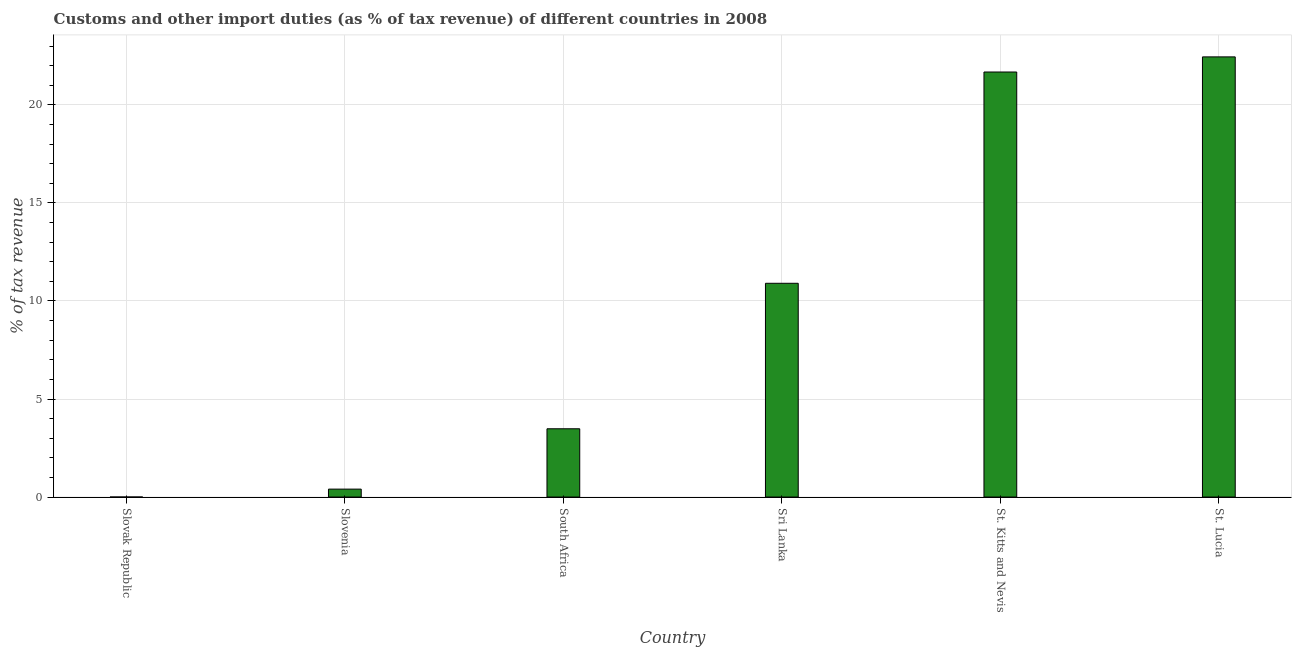Does the graph contain grids?
Offer a very short reply. Yes. What is the title of the graph?
Your answer should be compact. Customs and other import duties (as % of tax revenue) of different countries in 2008. What is the label or title of the X-axis?
Your answer should be very brief. Country. What is the label or title of the Y-axis?
Your answer should be very brief. % of tax revenue. What is the customs and other import duties in South Africa?
Your answer should be compact. 3.48. Across all countries, what is the maximum customs and other import duties?
Make the answer very short. 22.45. Across all countries, what is the minimum customs and other import duties?
Provide a short and direct response. 0. In which country was the customs and other import duties maximum?
Give a very brief answer. St. Lucia. In which country was the customs and other import duties minimum?
Your response must be concise. Slovak Republic. What is the sum of the customs and other import duties?
Ensure brevity in your answer.  58.92. What is the difference between the customs and other import duties in Slovenia and St. Lucia?
Provide a short and direct response. -22.05. What is the average customs and other import duties per country?
Offer a terse response. 9.82. What is the median customs and other import duties?
Your response must be concise. 7.19. In how many countries, is the customs and other import duties greater than 5 %?
Offer a terse response. 3. What is the ratio of the customs and other import duties in St. Kitts and Nevis to that in St. Lucia?
Offer a very short reply. 0.97. Is the customs and other import duties in Slovak Republic less than that in Sri Lanka?
Offer a very short reply. Yes. Is the difference between the customs and other import duties in South Africa and St. Lucia greater than the difference between any two countries?
Your answer should be very brief. No. What is the difference between the highest and the second highest customs and other import duties?
Give a very brief answer. 0.77. What is the difference between the highest and the lowest customs and other import duties?
Offer a very short reply. 22.45. How many bars are there?
Provide a succinct answer. 6. How many countries are there in the graph?
Keep it short and to the point. 6. What is the difference between two consecutive major ticks on the Y-axis?
Provide a succinct answer. 5. What is the % of tax revenue in Slovak Republic?
Your answer should be very brief. 0. What is the % of tax revenue in Slovenia?
Provide a succinct answer. 0.4. What is the % of tax revenue of South Africa?
Give a very brief answer. 3.48. What is the % of tax revenue in Sri Lanka?
Your answer should be very brief. 10.9. What is the % of tax revenue of St. Kitts and Nevis?
Keep it short and to the point. 21.68. What is the % of tax revenue of St. Lucia?
Provide a short and direct response. 22.45. What is the difference between the % of tax revenue in Slovak Republic and Slovenia?
Ensure brevity in your answer.  -0.4. What is the difference between the % of tax revenue in Slovak Republic and South Africa?
Provide a succinct answer. -3.48. What is the difference between the % of tax revenue in Slovak Republic and Sri Lanka?
Your response must be concise. -10.9. What is the difference between the % of tax revenue in Slovak Republic and St. Kitts and Nevis?
Keep it short and to the point. -21.68. What is the difference between the % of tax revenue in Slovak Republic and St. Lucia?
Your answer should be compact. -22.45. What is the difference between the % of tax revenue in Slovenia and South Africa?
Offer a very short reply. -3.08. What is the difference between the % of tax revenue in Slovenia and Sri Lanka?
Provide a succinct answer. -10.5. What is the difference between the % of tax revenue in Slovenia and St. Kitts and Nevis?
Provide a short and direct response. -21.27. What is the difference between the % of tax revenue in Slovenia and St. Lucia?
Offer a terse response. -22.05. What is the difference between the % of tax revenue in South Africa and Sri Lanka?
Ensure brevity in your answer.  -7.42. What is the difference between the % of tax revenue in South Africa and St. Kitts and Nevis?
Your response must be concise. -18.2. What is the difference between the % of tax revenue in South Africa and St. Lucia?
Offer a terse response. -18.97. What is the difference between the % of tax revenue in Sri Lanka and St. Kitts and Nevis?
Provide a succinct answer. -10.78. What is the difference between the % of tax revenue in Sri Lanka and St. Lucia?
Provide a short and direct response. -11.55. What is the difference between the % of tax revenue in St. Kitts and Nevis and St. Lucia?
Make the answer very short. -0.77. What is the ratio of the % of tax revenue in Slovak Republic to that in St. Lucia?
Your response must be concise. 0. What is the ratio of the % of tax revenue in Slovenia to that in South Africa?
Give a very brief answer. 0.12. What is the ratio of the % of tax revenue in Slovenia to that in Sri Lanka?
Offer a very short reply. 0.04. What is the ratio of the % of tax revenue in Slovenia to that in St. Kitts and Nevis?
Your answer should be very brief. 0.02. What is the ratio of the % of tax revenue in Slovenia to that in St. Lucia?
Your response must be concise. 0.02. What is the ratio of the % of tax revenue in South Africa to that in Sri Lanka?
Give a very brief answer. 0.32. What is the ratio of the % of tax revenue in South Africa to that in St. Kitts and Nevis?
Offer a very short reply. 0.16. What is the ratio of the % of tax revenue in South Africa to that in St. Lucia?
Ensure brevity in your answer.  0.15. What is the ratio of the % of tax revenue in Sri Lanka to that in St. Kitts and Nevis?
Give a very brief answer. 0.5. What is the ratio of the % of tax revenue in Sri Lanka to that in St. Lucia?
Offer a terse response. 0.49. 